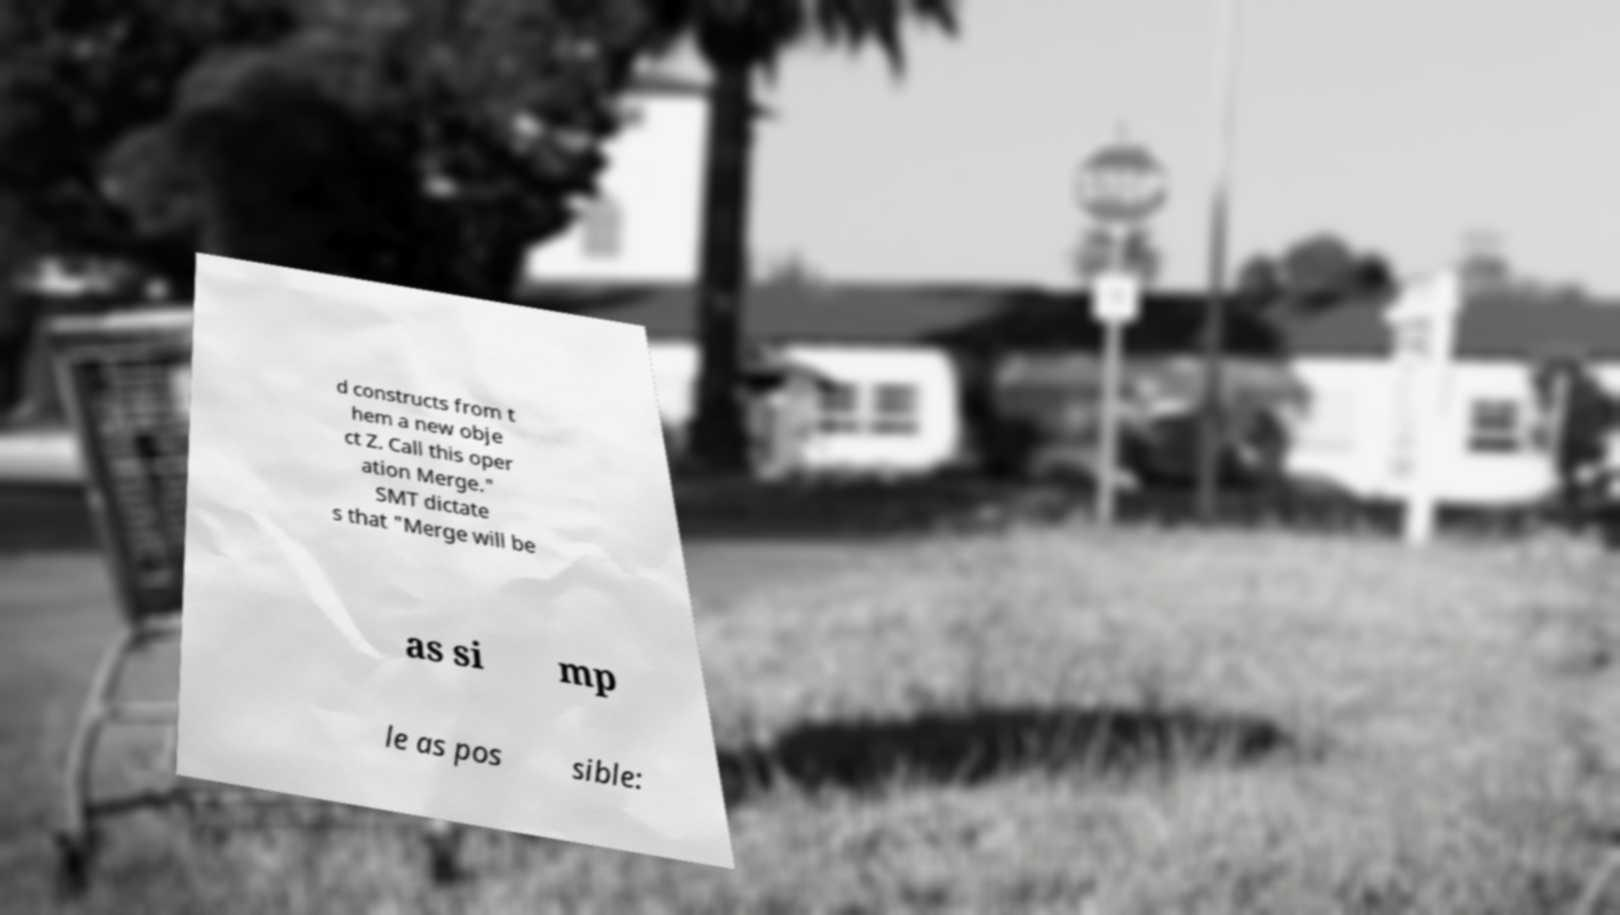Please identify and transcribe the text found in this image. d constructs from t hem a new obje ct Z. Call this oper ation Merge." SMT dictate s that "Merge will be as si mp le as pos sible: 